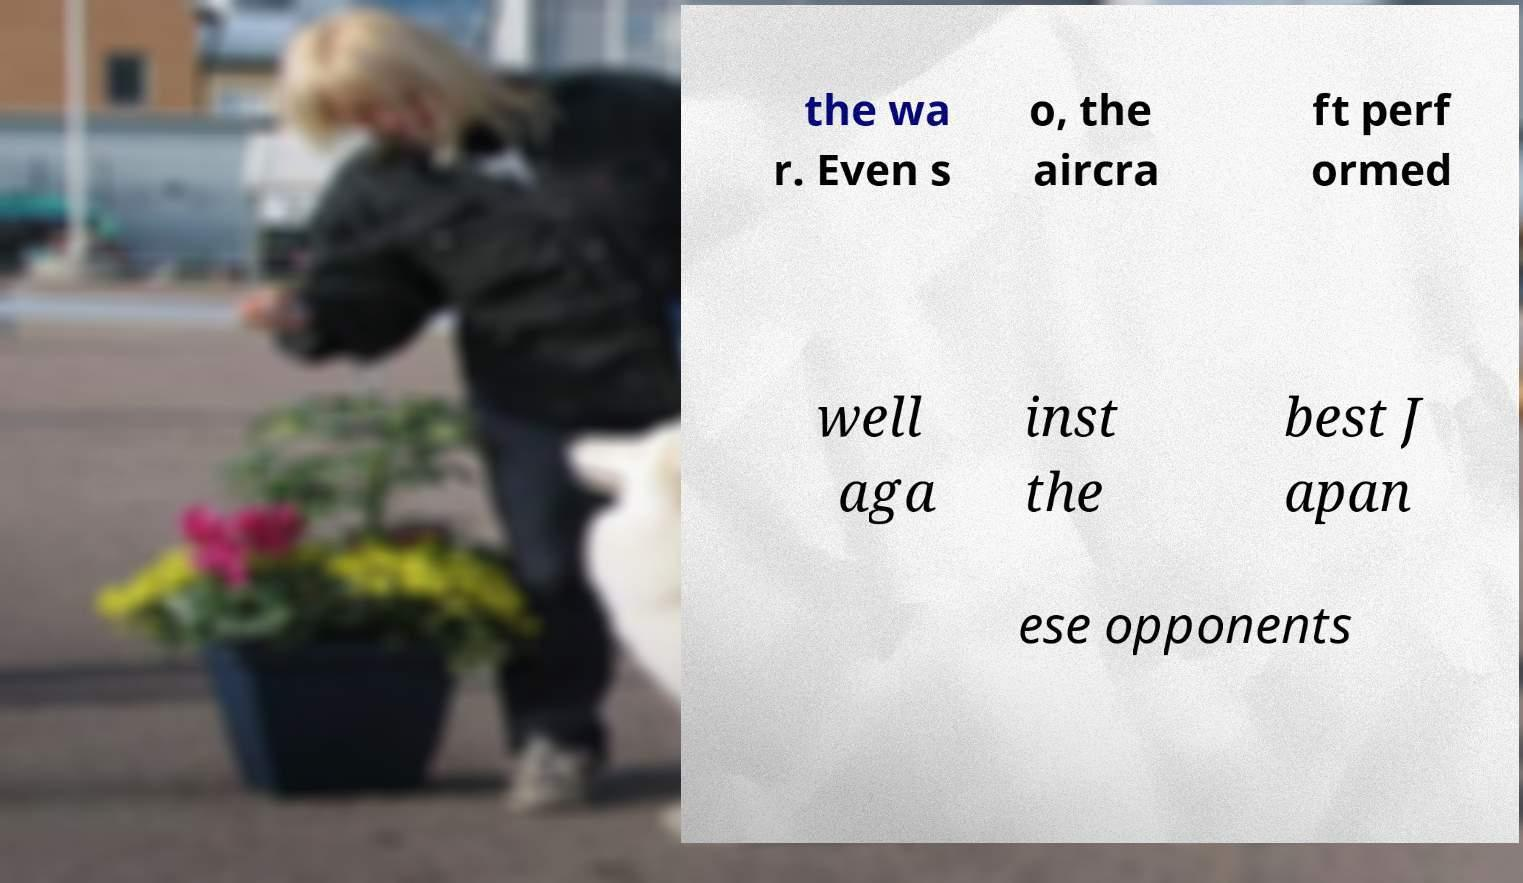Please identify and transcribe the text found in this image. the wa r. Even s o, the aircra ft perf ormed well aga inst the best J apan ese opponents 